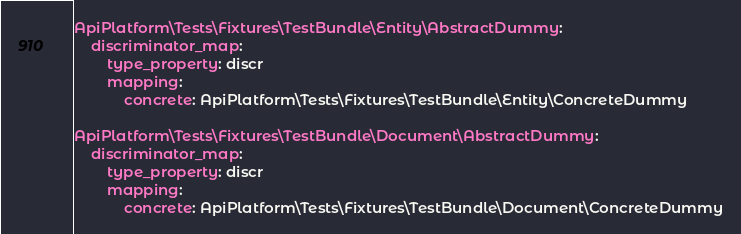<code> <loc_0><loc_0><loc_500><loc_500><_YAML_>ApiPlatform\Tests\Fixtures\TestBundle\Entity\AbstractDummy:
    discriminator_map:
        type_property: discr
        mapping:
            concrete: ApiPlatform\Tests\Fixtures\TestBundle\Entity\ConcreteDummy

ApiPlatform\Tests\Fixtures\TestBundle\Document\AbstractDummy:
    discriminator_map:
        type_property: discr
        mapping:
            concrete: ApiPlatform\Tests\Fixtures\TestBundle\Document\ConcreteDummy
</code> 